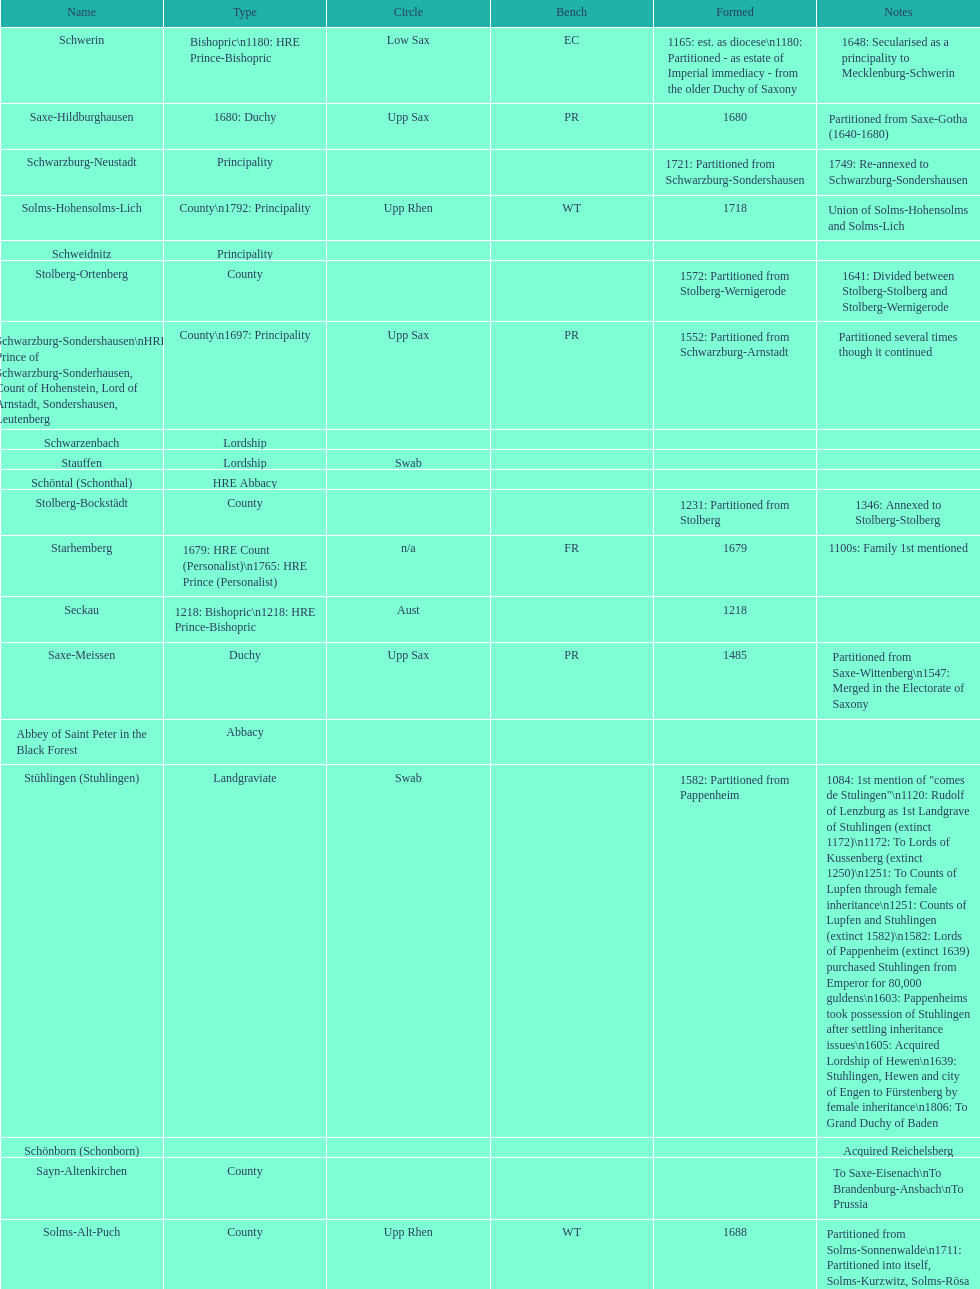What is the state above "sagan"? Saarwerden and Lahr. 